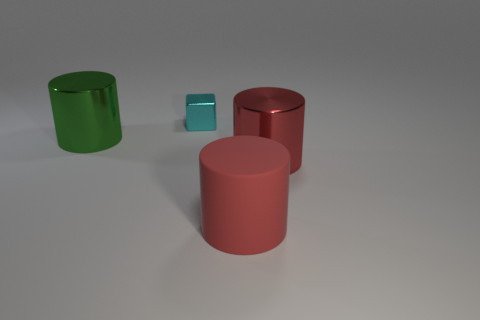Add 3 big metallic things. How many objects exist? 7 Subtract all cylinders. How many objects are left? 1 Add 4 big objects. How many big objects are left? 7 Add 2 large green metal things. How many large green metal things exist? 3 Subtract 0 red cubes. How many objects are left? 4 Subtract all tiny gray shiny spheres. Subtract all big metallic objects. How many objects are left? 2 